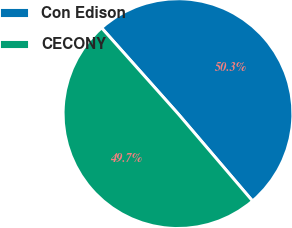Convert chart. <chart><loc_0><loc_0><loc_500><loc_500><pie_chart><fcel>Con Edison<fcel>CECONY<nl><fcel>50.34%<fcel>49.66%<nl></chart> 